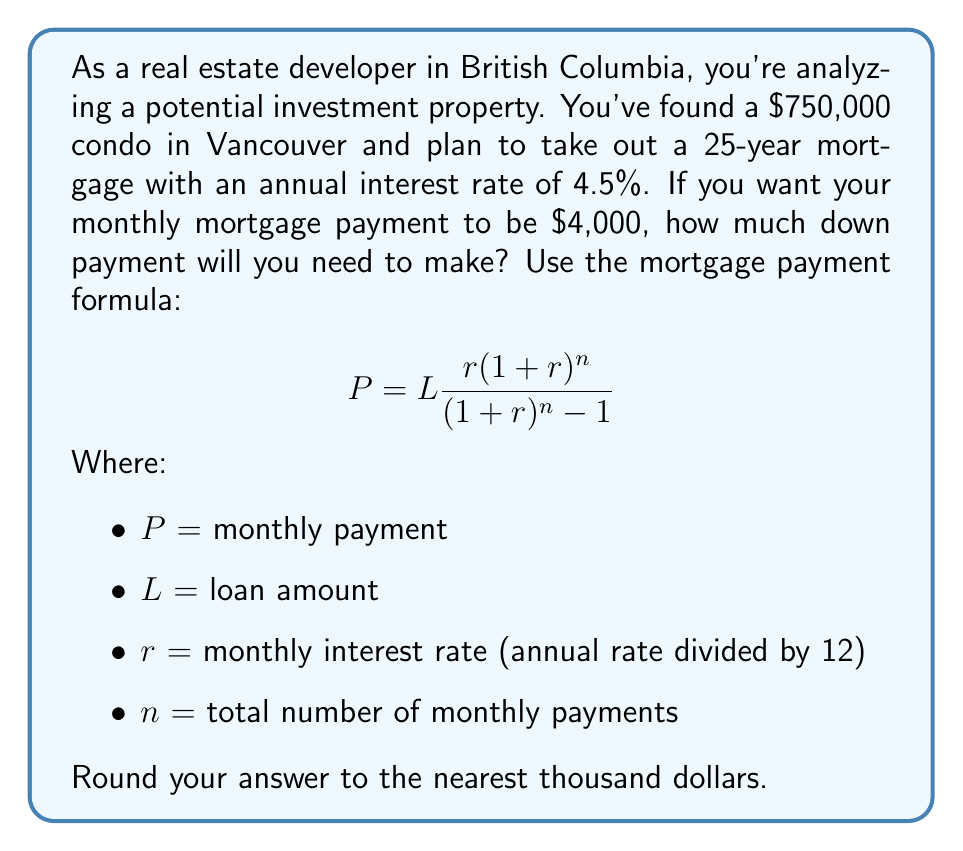Can you solve this math problem? Let's approach this step-by-step:

1) First, we need to rearrange the formula to solve for $L$ (loan amount):

   $$L = P\frac{(1+r)^n-1}{r(1+r)^n}$$

2) We know:
   $P = 4000$ (monthly payment)
   $r = 0.045 / 12 = 0.00375$ (monthly interest rate)
   $n = 25 * 12 = 300$ (total number of monthly payments)

3) Let's substitute these values:

   $$L = 4000\frac{(1+0.00375)^{300}-1}{0.00375(1+0.00375)^{300}}$$

4) This is a complex calculation, so let's use a calculator or spreadsheet:

   $L \approx 697,421.37$

5) This means the loan amount would be about $697,421. 

6) The property costs $750,000, so the down payment would be:

   $750,000 - 697,421 = 52,579$

7) Rounding to the nearest thousand:

   Down payment = $53,000
Answer: $53,000 